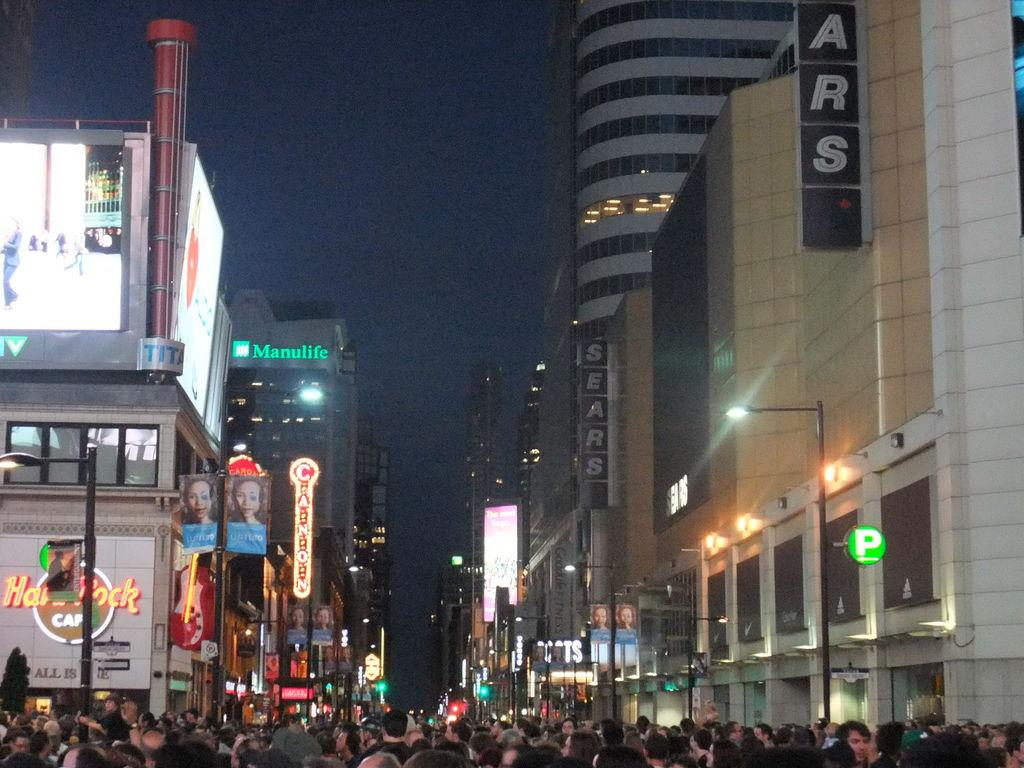<image>
Summarize the visual content of the image. The Hard Rock Cafe is seen on a busy city street. 